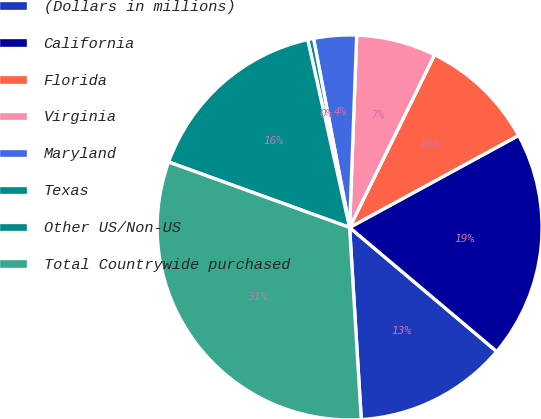Convert chart. <chart><loc_0><loc_0><loc_500><loc_500><pie_chart><fcel>(Dollars in millions)<fcel>California<fcel>Florida<fcel>Virginia<fcel>Maryland<fcel>Texas<fcel>Other US/Non-US<fcel>Total Countrywide purchased<nl><fcel>12.89%<fcel>19.09%<fcel>9.79%<fcel>6.69%<fcel>3.59%<fcel>0.49%<fcel>15.99%<fcel>31.49%<nl></chart> 